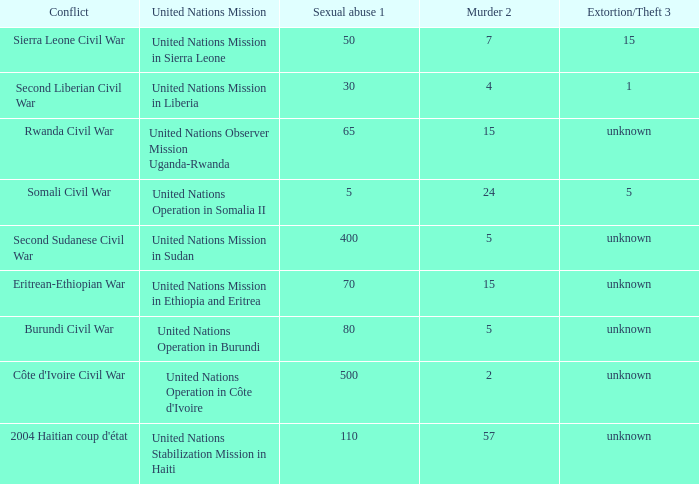What is the sexual abuse rate where the conflict is the Burundi Civil War? 80.0. 